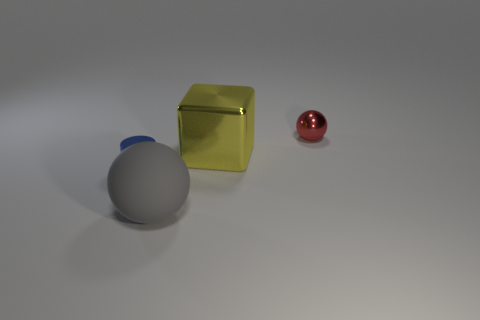What number of large things are cylinders or yellow rubber cubes?
Provide a succinct answer. 0. There is a big thing that is on the left side of the big yellow thing; is there a metal thing behind it?
Your answer should be very brief. Yes. Is there a green sphere?
Make the answer very short. No. What is the color of the thing that is to the left of the sphere in front of the small sphere?
Offer a very short reply. Blue. There is another red object that is the same shape as the big rubber object; what is it made of?
Give a very brief answer. Metal. What number of yellow metallic blocks are the same size as the gray rubber object?
Your answer should be compact. 1. The cylinder that is made of the same material as the yellow object is what size?
Offer a terse response. Small. What number of small red objects are the same shape as the big matte thing?
Your answer should be very brief. 1. What number of tiny red objects are there?
Offer a terse response. 1. Does the small thing that is right of the big rubber thing have the same shape as the big gray object?
Make the answer very short. Yes. 